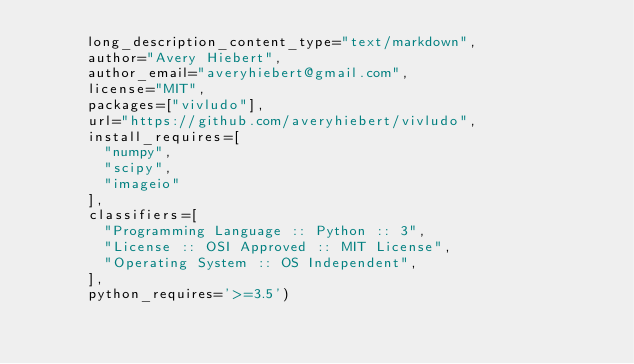<code> <loc_0><loc_0><loc_500><loc_500><_Python_>      long_description_content_type="text/markdown",
      author="Avery Hiebert",
      author_email="averyhiebert@gmail.com",
      license="MIT",
      packages=["vivludo"],
      url="https://github.com/averyhiebert/vivludo",
      install_requires=[
        "numpy",
        "scipy",
        "imageio"
      ],
      classifiers=[
        "Programming Language :: Python :: 3",
        "License :: OSI Approved :: MIT License",
        "Operating System :: OS Independent",
      ],
      python_requires='>=3.5')
</code> 